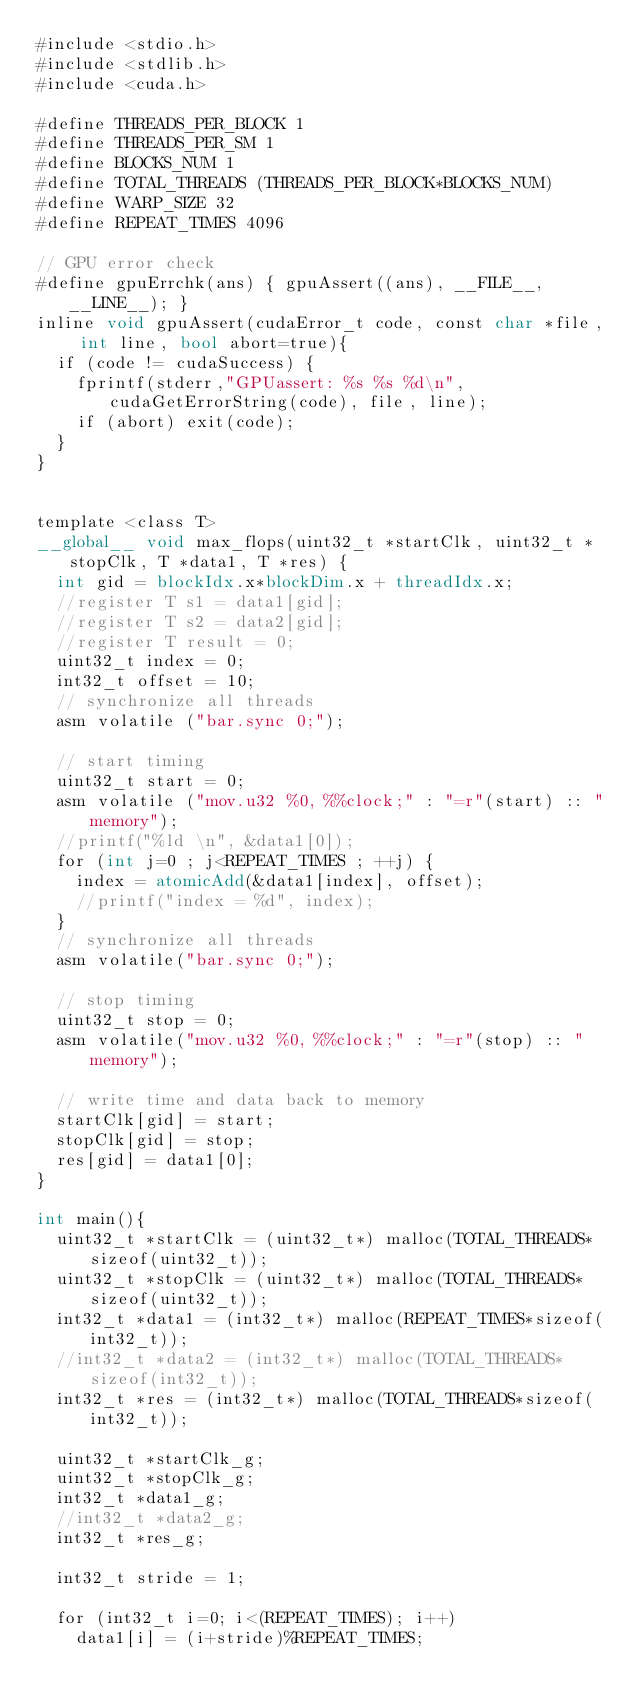<code> <loc_0><loc_0><loc_500><loc_500><_Cuda_>#include <stdio.h>   
#include <stdlib.h> 
#include <cuda.h>

#define THREADS_PER_BLOCK 1
#define THREADS_PER_SM 1
#define BLOCKS_NUM 1
#define TOTAL_THREADS (THREADS_PER_BLOCK*BLOCKS_NUM)
#define WARP_SIZE 32
#define REPEAT_TIMES 4096

// GPU error check
#define gpuErrchk(ans) { gpuAssert((ans), __FILE__, __LINE__); }
inline void gpuAssert(cudaError_t code, const char *file, int line, bool abort=true){
	if (code != cudaSuccess) {
		fprintf(stderr,"GPUassert: %s %s %d\n", cudaGetErrorString(code), file, line);
		if (abort) exit(code);
	}
}


template <class T>
__global__ void max_flops(uint32_t *startClk, uint32_t *stopClk, T *data1, T *res) {
	int gid = blockIdx.x*blockDim.x + threadIdx.x;
	//register T s1 = data1[gid];
	//register T s2 = data2[gid];
	//register T result = 0;
	uint32_t index = 0;
	int32_t offset = 10;
	// synchronize all threads
	asm volatile ("bar.sync 0;");
	
	// start timing
	uint32_t start = 0;
	asm volatile ("mov.u32 %0, %%clock;" : "=r"(start) :: "memory");
	//printf("%ld \n", &data1[0]);
	for (int j=0 ; j<REPEAT_TIMES ; ++j) {
		index = atomicAdd(&data1[index], offset);
		//printf("index = %d", index);
	}
	// synchronize all threads
	asm volatile("bar.sync 0;");

	// stop timing
	uint32_t stop = 0;
	asm volatile("mov.u32 %0, %%clock;" : "=r"(stop) :: "memory");

	// write time and data back to memory
	startClk[gid] = start;
	stopClk[gid] = stop;
	res[gid] = data1[0];
}

int main(){
	uint32_t *startClk = (uint32_t*) malloc(TOTAL_THREADS*sizeof(uint32_t));
	uint32_t *stopClk = (uint32_t*) malloc(TOTAL_THREADS*sizeof(uint32_t));
	int32_t *data1 = (int32_t*) malloc(REPEAT_TIMES*sizeof(int32_t));
	//int32_t *data2 = (int32_t*) malloc(TOTAL_THREADS*sizeof(int32_t));
	int32_t *res = (int32_t*) malloc(TOTAL_THREADS*sizeof(int32_t));

	uint32_t *startClk_g;
	uint32_t *stopClk_g;
	int32_t *data1_g;
	//int32_t *data2_g;
	int32_t *res_g;

	int32_t stride = 1;

	for (int32_t i=0; i<(REPEAT_TIMES); i++)
		data1[i] = (i+stride)%REPEAT_TIMES;

</code> 